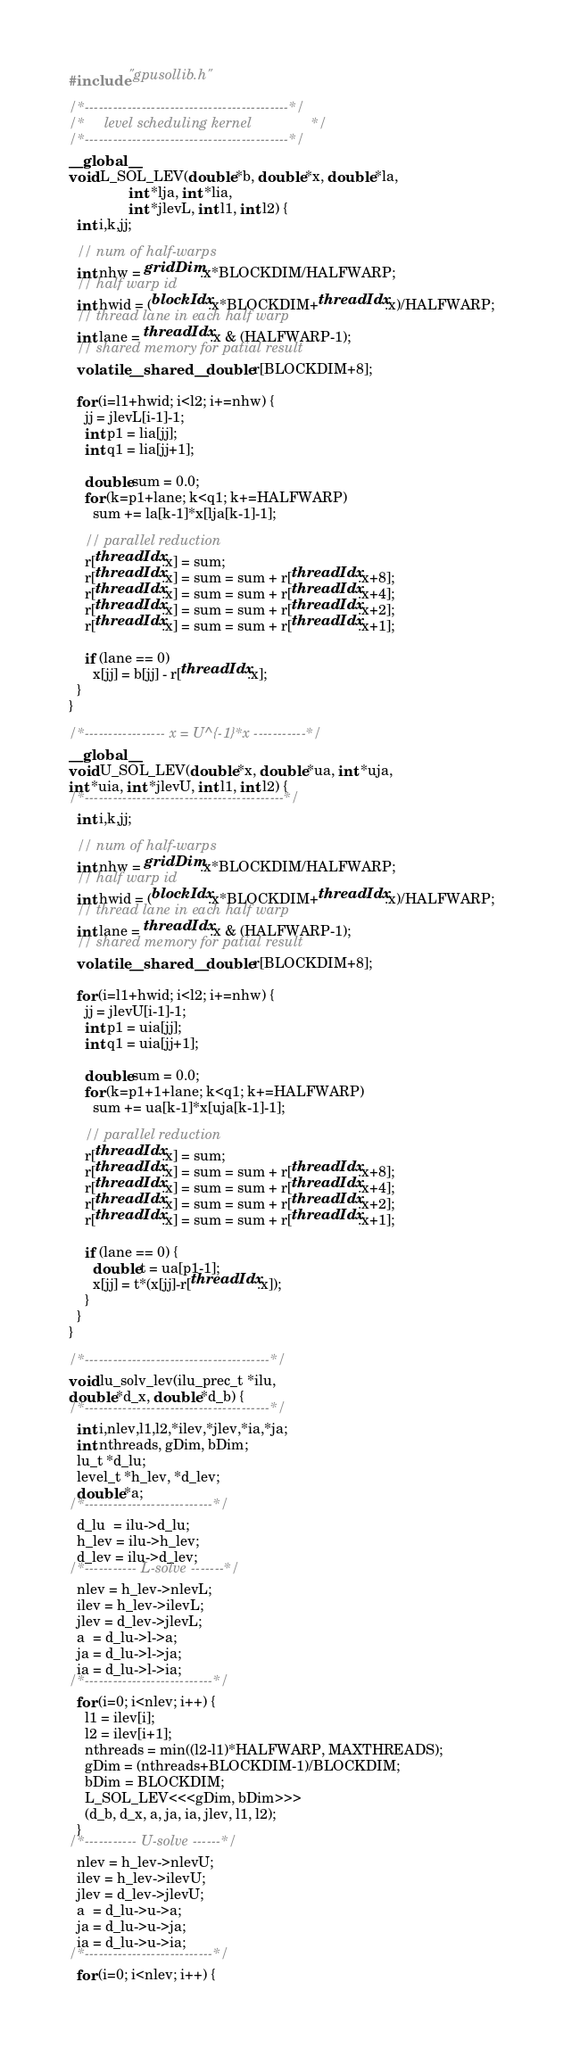<code> <loc_0><loc_0><loc_500><loc_500><_Cuda_>#include "gpusollib.h"

/*-------------------------------------------*/
/*     level scheduling kernel               */
/*-------------------------------------------*/
__global__
void L_SOL_LEV(double *b, double *x, double *la, 
               int *lja, int *lia,
               int *jlevL, int l1, int l2) {
  int i,k,jj;

  // num of half-warps
  int nhw = gridDim.x*BLOCKDIM/HALFWARP;
  // half warp id
  int hwid = (blockIdx.x*BLOCKDIM+threadIdx.x)/HALFWARP;
  // thread lane in each half warp
  int lane = threadIdx.x & (HALFWARP-1);
  // shared memory for patial result
  volatile __shared__ double r[BLOCKDIM+8];

  for (i=l1+hwid; i<l2; i+=nhw) {
    jj = jlevL[i-1]-1;
    int p1 = lia[jj];
    int q1 = lia[jj+1];

    double sum = 0.0;
    for (k=p1+lane; k<q1; k+=HALFWARP)
      sum += la[k-1]*x[lja[k-1]-1];

    // parallel reduction
    r[threadIdx.x] = sum;
    r[threadIdx.x] = sum = sum + r[threadIdx.x+8];
    r[threadIdx.x] = sum = sum + r[threadIdx.x+4];
    r[threadIdx.x] = sum = sum + r[threadIdx.x+2];
    r[threadIdx.x] = sum = sum + r[threadIdx.x+1];

    if (lane == 0)
      x[jj] = b[jj] - r[threadIdx.x];
  }
}

/*----------------- x = U^{-1}*x -----------*/
__global__
void U_SOL_LEV(double *x, double *ua, int *uja, 
int *uia, int *jlevU, int l1, int l2) {
/*------------------------------------------*/
  int i,k,jj;

  // num of half-warps
  int nhw = gridDim.x*BLOCKDIM/HALFWARP;
  // half warp id
  int hwid = (blockIdx.x*BLOCKDIM+threadIdx.x)/HALFWARP;
  // thread lane in each half warp
  int lane = threadIdx.x & (HALFWARP-1);
  // shared memory for patial result
  volatile __shared__ double r[BLOCKDIM+8];

  for (i=l1+hwid; i<l2; i+=nhw) {
    jj = jlevU[i-1]-1;
    int p1 = uia[jj];
    int q1 = uia[jj+1];

    double sum = 0.0;
    for (k=p1+1+lane; k<q1; k+=HALFWARP)
      sum += ua[k-1]*x[uja[k-1]-1];

    // parallel reduction
    r[threadIdx.x] = sum;
    r[threadIdx.x] = sum = sum + r[threadIdx.x+8];
    r[threadIdx.x] = sum = sum + r[threadIdx.x+4];
    r[threadIdx.x] = sum = sum + r[threadIdx.x+2];
    r[threadIdx.x] = sum = sum + r[threadIdx.x+1];

    if (lane == 0) {
      double t = ua[p1-1];
      x[jj] = t*(x[jj]-r[threadIdx.x]);
    }
  }
}

/*---------------------------------------*/
void lu_solv_lev(ilu_prec_t *ilu, 
double *d_x, double *d_b) {
/*---------------------------------------*/
  int i,nlev,l1,l2,*ilev,*jlev,*ia,*ja;
  int nthreads, gDim, bDim;
  lu_t *d_lu;
  level_t *h_lev, *d_lev;
  double *a;
/*---------------------------*/
  d_lu  = ilu->d_lu;
  h_lev = ilu->h_lev;
  d_lev = ilu->d_lev;
/*----------- L-solve -------*/
  nlev = h_lev->nlevL;
  ilev = h_lev->ilevL;
  jlev = d_lev->jlevL;
  a  = d_lu->l->a;
  ja = d_lu->l->ja;
  ia = d_lu->l->ia;
/*---------------------------*/
  for (i=0; i<nlev; i++) {
    l1 = ilev[i];
    l2 = ilev[i+1];
    nthreads = min((l2-l1)*HALFWARP, MAXTHREADS);
    gDim = (nthreads+BLOCKDIM-1)/BLOCKDIM;
    bDim = BLOCKDIM;
    L_SOL_LEV<<<gDim, bDim>>>
    (d_b, d_x, a, ja, ia, jlev, l1, l2);
  }
/*----------- U-solve ------*/
  nlev = h_lev->nlevU;
  ilev = h_lev->ilevU;
  jlev = d_lev->jlevU;
  a  = d_lu->u->a;
  ja = d_lu->u->ja;
  ia = d_lu->u->ia;
/*---------------------------*/
  for (i=0; i<nlev; i++) {</code> 